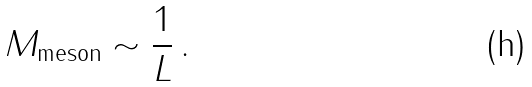Convert formula to latex. <formula><loc_0><loc_0><loc_500><loc_500>M _ { \text {meson} } \sim \frac { 1 } { L } \, .</formula> 